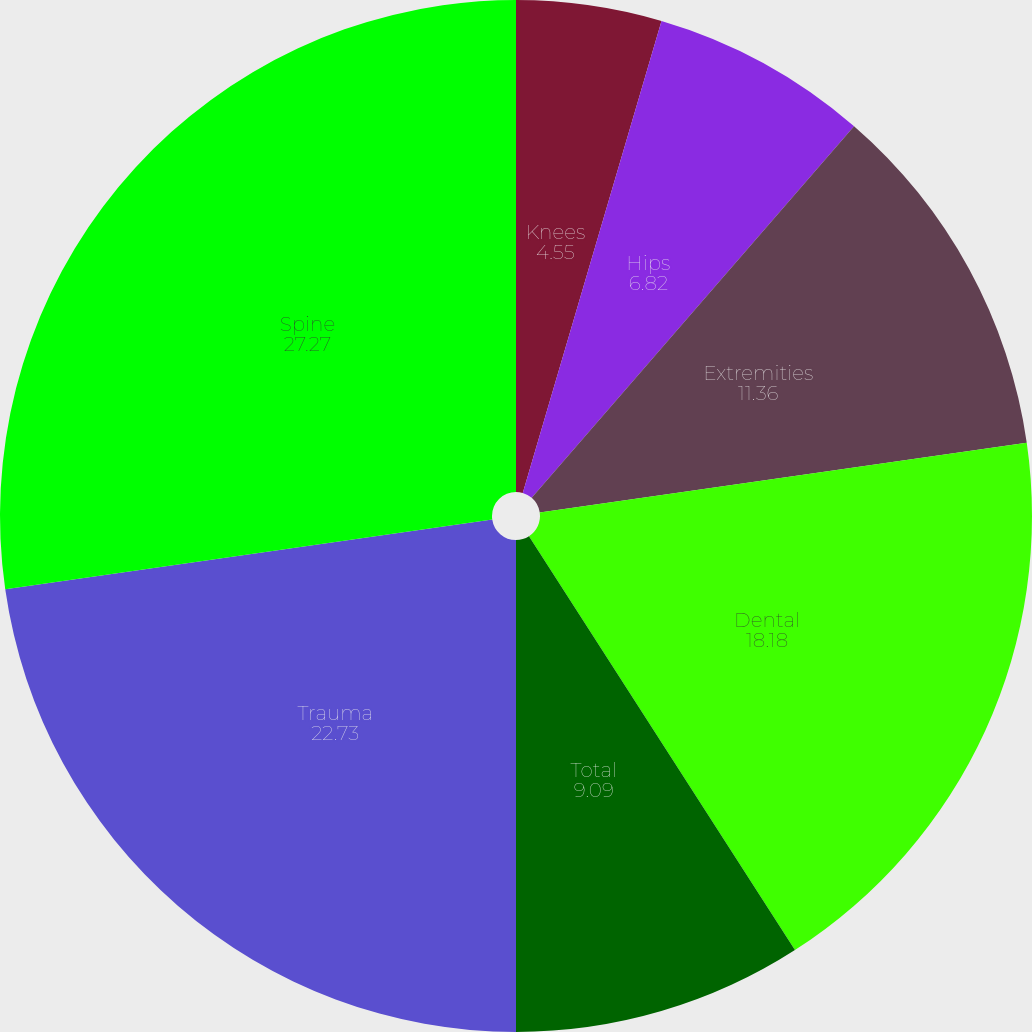Convert chart to OTSL. <chart><loc_0><loc_0><loc_500><loc_500><pie_chart><fcel>Knees<fcel>Hips<fcel>Extremities<fcel>Dental<fcel>Total<fcel>Trauma<fcel>Spine<nl><fcel>4.55%<fcel>6.82%<fcel>11.36%<fcel>18.18%<fcel>9.09%<fcel>22.73%<fcel>27.27%<nl></chart> 